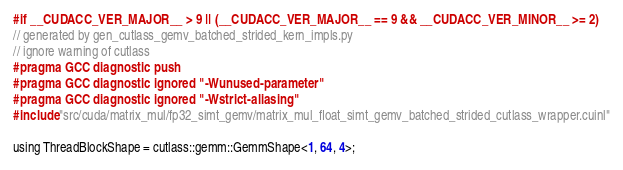Convert code to text. <code><loc_0><loc_0><loc_500><loc_500><_Cuda_>#if __CUDACC_VER_MAJOR__ > 9 || (__CUDACC_VER_MAJOR__ == 9 && __CUDACC_VER_MINOR__ >= 2)
// generated by gen_cutlass_gemv_batched_strided_kern_impls.py
// ignore warning of cutlass
#pragma GCC diagnostic push
#pragma GCC diagnostic ignored "-Wunused-parameter"
#pragma GCC diagnostic ignored "-Wstrict-aliasing"
#include "src/cuda/matrix_mul/fp32_simt_gemv/matrix_mul_float_simt_gemv_batched_strided_cutlass_wrapper.cuinl"

using ThreadBlockShape = cutlass::gemm::GemmShape<1, 64, 4>;</code> 